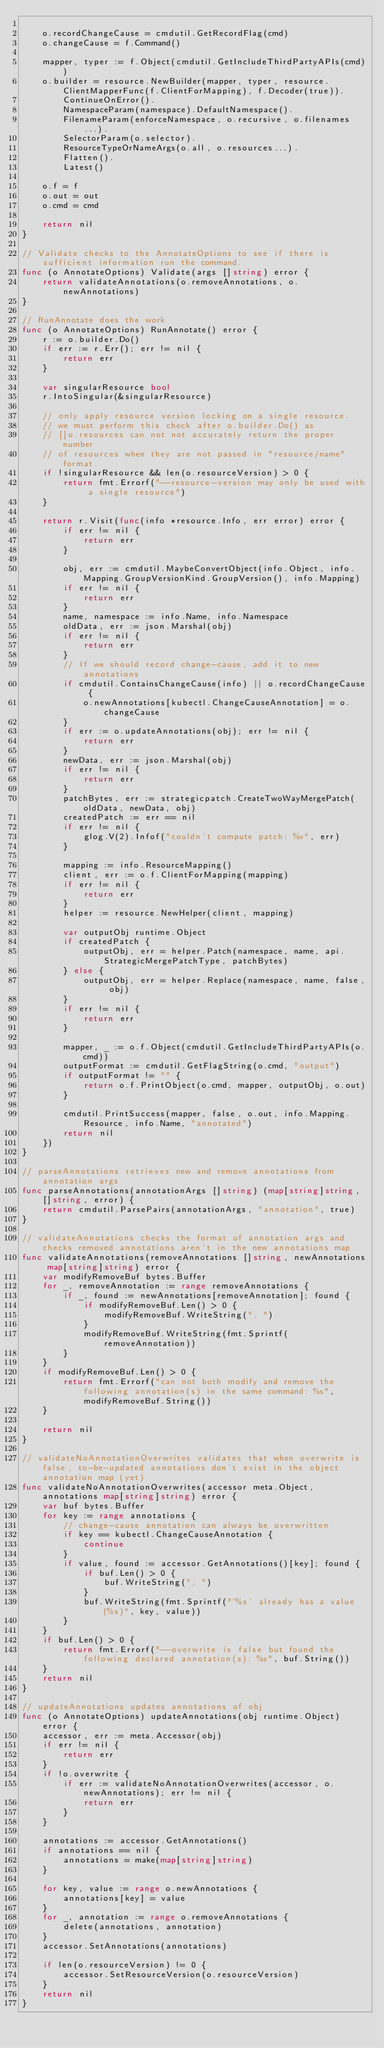Convert code to text. <code><loc_0><loc_0><loc_500><loc_500><_Go_>
	o.recordChangeCause = cmdutil.GetRecordFlag(cmd)
	o.changeCause = f.Command()

	mapper, typer := f.Object(cmdutil.GetIncludeThirdPartyAPIs(cmd))
	o.builder = resource.NewBuilder(mapper, typer, resource.ClientMapperFunc(f.ClientForMapping), f.Decoder(true)).
		ContinueOnError().
		NamespaceParam(namespace).DefaultNamespace().
		FilenameParam(enforceNamespace, o.recursive, o.filenames...).
		SelectorParam(o.selector).
		ResourceTypeOrNameArgs(o.all, o.resources...).
		Flatten().
		Latest()

	o.f = f
	o.out = out
	o.cmd = cmd

	return nil
}

// Validate checks to the AnnotateOptions to see if there is sufficient information run the command.
func (o AnnotateOptions) Validate(args []string) error {
	return validateAnnotations(o.removeAnnotations, o.newAnnotations)
}

// RunAnnotate does the work
func (o AnnotateOptions) RunAnnotate() error {
	r := o.builder.Do()
	if err := r.Err(); err != nil {
		return err
	}

	var singularResource bool
	r.IntoSingular(&singularResource)

	// only apply resource version locking on a single resource.
	// we must perform this check after o.builder.Do() as
	// []o.resources can not not accurately return the proper number
	// of resources when they are not passed in "resource/name" format.
	if !singularResource && len(o.resourceVersion) > 0 {
		return fmt.Errorf("--resource-version may only be used with a single resource")
	}

	return r.Visit(func(info *resource.Info, err error) error {
		if err != nil {
			return err
		}

		obj, err := cmdutil.MaybeConvertObject(info.Object, info.Mapping.GroupVersionKind.GroupVersion(), info.Mapping)
		if err != nil {
			return err
		}
		name, namespace := info.Name, info.Namespace
		oldData, err := json.Marshal(obj)
		if err != nil {
			return err
		}
		// If we should record change-cause, add it to new annotations
		if cmdutil.ContainsChangeCause(info) || o.recordChangeCause {
			o.newAnnotations[kubectl.ChangeCauseAnnotation] = o.changeCause
		}
		if err := o.updateAnnotations(obj); err != nil {
			return err
		}
		newData, err := json.Marshal(obj)
		if err != nil {
			return err
		}
		patchBytes, err := strategicpatch.CreateTwoWayMergePatch(oldData, newData, obj)
		createdPatch := err == nil
		if err != nil {
			glog.V(2).Infof("couldn't compute patch: %v", err)
		}

		mapping := info.ResourceMapping()
		client, err := o.f.ClientForMapping(mapping)
		if err != nil {
			return err
		}
		helper := resource.NewHelper(client, mapping)

		var outputObj runtime.Object
		if createdPatch {
			outputObj, err = helper.Patch(namespace, name, api.StrategicMergePatchType, patchBytes)
		} else {
			outputObj, err = helper.Replace(namespace, name, false, obj)
		}
		if err != nil {
			return err
		}

		mapper, _ := o.f.Object(cmdutil.GetIncludeThirdPartyAPIs(o.cmd))
		outputFormat := cmdutil.GetFlagString(o.cmd, "output")
		if outputFormat != "" {
			return o.f.PrintObject(o.cmd, mapper, outputObj, o.out)
		}

		cmdutil.PrintSuccess(mapper, false, o.out, info.Mapping.Resource, info.Name, "annotated")
		return nil
	})
}

// parseAnnotations retrieves new and remove annotations from annotation args
func parseAnnotations(annotationArgs []string) (map[string]string, []string, error) {
	return cmdutil.ParsePairs(annotationArgs, "annotation", true)
}

// validateAnnotations checks the format of annotation args and checks removed annotations aren't in the new annotations map
func validateAnnotations(removeAnnotations []string, newAnnotations map[string]string) error {
	var modifyRemoveBuf bytes.Buffer
	for _, removeAnnotation := range removeAnnotations {
		if _, found := newAnnotations[removeAnnotation]; found {
			if modifyRemoveBuf.Len() > 0 {
				modifyRemoveBuf.WriteString(", ")
			}
			modifyRemoveBuf.WriteString(fmt.Sprintf(removeAnnotation))
		}
	}
	if modifyRemoveBuf.Len() > 0 {
		return fmt.Errorf("can not both modify and remove the following annotation(s) in the same command: %s", modifyRemoveBuf.String())
	}

	return nil
}

// validateNoAnnotationOverwrites validates that when overwrite is false, to-be-updated annotations don't exist in the object annotation map (yet)
func validateNoAnnotationOverwrites(accessor meta.Object, annotations map[string]string) error {
	var buf bytes.Buffer
	for key := range annotations {
		// change-cause annotation can always be overwritten
		if key == kubectl.ChangeCauseAnnotation {
			continue
		}
		if value, found := accessor.GetAnnotations()[key]; found {
			if buf.Len() > 0 {
				buf.WriteString("; ")
			}
			buf.WriteString(fmt.Sprintf("'%s' already has a value (%s)", key, value))
		}
	}
	if buf.Len() > 0 {
		return fmt.Errorf("--overwrite is false but found the following declared annotation(s): %s", buf.String())
	}
	return nil
}

// updateAnnotations updates annotations of obj
func (o AnnotateOptions) updateAnnotations(obj runtime.Object) error {
	accessor, err := meta.Accessor(obj)
	if err != nil {
		return err
	}
	if !o.overwrite {
		if err := validateNoAnnotationOverwrites(accessor, o.newAnnotations); err != nil {
			return err
		}
	}

	annotations := accessor.GetAnnotations()
	if annotations == nil {
		annotations = make(map[string]string)
	}

	for key, value := range o.newAnnotations {
		annotations[key] = value
	}
	for _, annotation := range o.removeAnnotations {
		delete(annotations, annotation)
	}
	accessor.SetAnnotations(annotations)

	if len(o.resourceVersion) != 0 {
		accessor.SetResourceVersion(o.resourceVersion)
	}
	return nil
}
</code> 